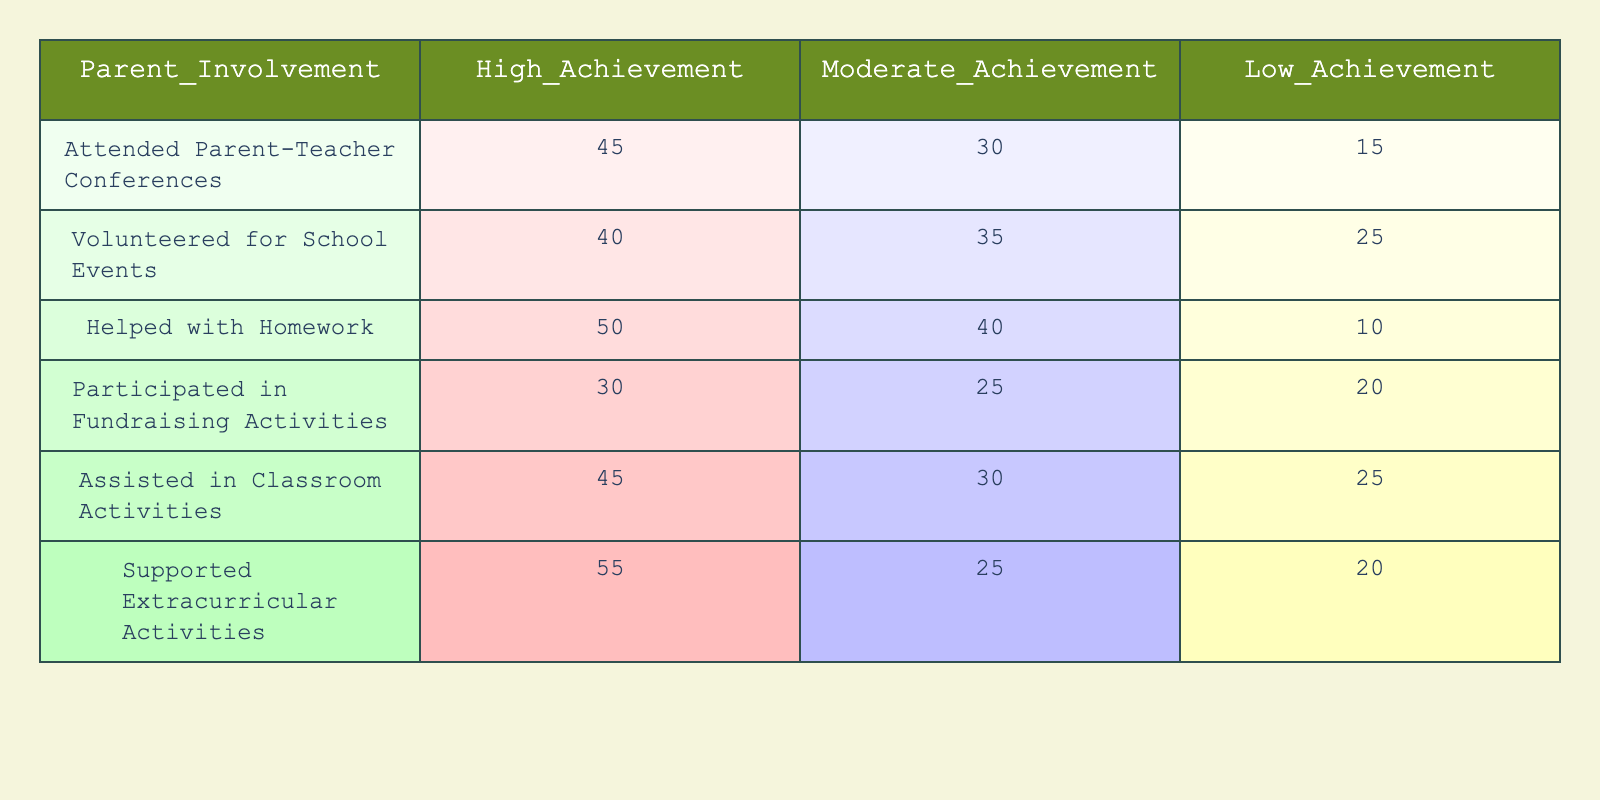What is the total number of High Achievement students who attended Parent-Teacher Conferences? Referring to the table, the number of High Achievement students who attended Parent-Teacher Conferences is given as 45.
Answer: 45 What is the number of Moderate Achievement students who volunteered for school events? According to the table, the number of Moderate Achievement students who volunteered for school events is listed as 35.
Answer: 35 Did more High Achievement students help with homework than Low Achievement students? Checking the respective figures in the table, 50 High Achievement students helped with homework while only 10 Low Achievement students did. Thus, the statement is true.
Answer: Yes What is the difference in participation between High Achievement and Low Achievement students who supported extracurricular activities? The number of High Achievement students is 55, while the number of Low Achievement students is 20. The difference is calculated as 55 - 20 = 35.
Answer: 35 What is the average number of students across all achievement levels that participated in fundraising activities? The number of students for each group participating in fundraising activities is 30 (High) + 25 (Moderate) + 20 (Low) = 75. To find the average, divide by 3: 75 / 3 = 25.
Answer: 25 How many more students helped with homework in High Achievement compared to Moderate Achievement? The number of students who helped with homework is 50 (High) and 40 (Moderate). The difference is 50 - 40 = 10.
Answer: 10 Is it true that the number of Low Achievement students attending Parent-Teacher Conferences is equal to those volunteering for school events? From the table, Low Achievement students attending Parent-Teacher Conferences is 15, while those volunteering for school events is 25. Since these numbers are not equal, the statement is false.
Answer: No What is the total number of students involved in Classroom Activities for all achievement levels? The total number of students involved in Classroom Activities is calculated by adding up the respective numbers: 45 (High) + 30 (Moderate) + 25 (Low) = 100.
Answer: 100 Which form of parent involvement had the highest number of High Achievement students? The data shows that the highest number of High Achievement students supported extracurricular activities with 55 students.
Answer: Supported Extracurricular Activities How many students in total volunteered compared to those who participated in fundraising activities? For volunteering, the total is 40 (High) + 35 (Moderate) + 25 (Low) = 100. For fundraising, it is 30 (High) + 25 (Moderate) + 20 (Low) = 75. The comparison shows that 100 > 75.
Answer: 100 vs 75 